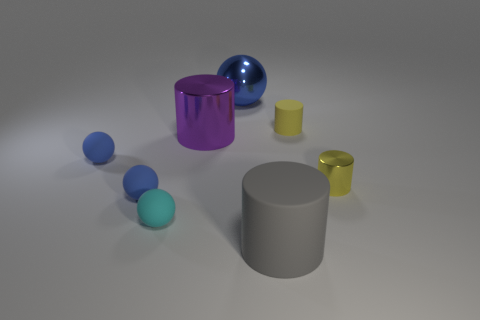Could you describe the lighting arrangement and shadows seen in this image? Certainly, the lighting in the image appears to be diffused, coming from an overhead source that casts soft, subtle shadows under and around the objects. The directionality of the shadows suggests a single light source. The intensity of the shadows varies, being softer and less defined on some objects, indicating that the light source is neither very close nor overly strong, allowing for a gentle gradation in the shadows. 